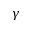<formula> <loc_0><loc_0><loc_500><loc_500>\gamma</formula> 